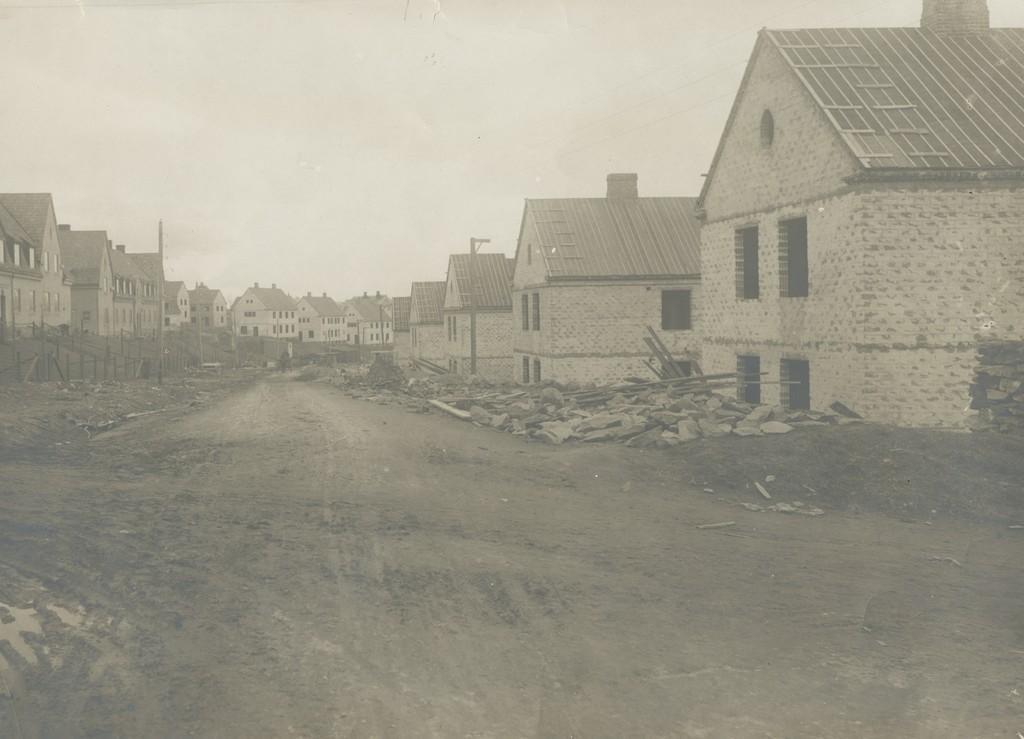Describe this image in one or two sentences. In this picture we can see the ground, stones, sticks, poles, some objects, buildings with windows and in the background we can see the sky. 